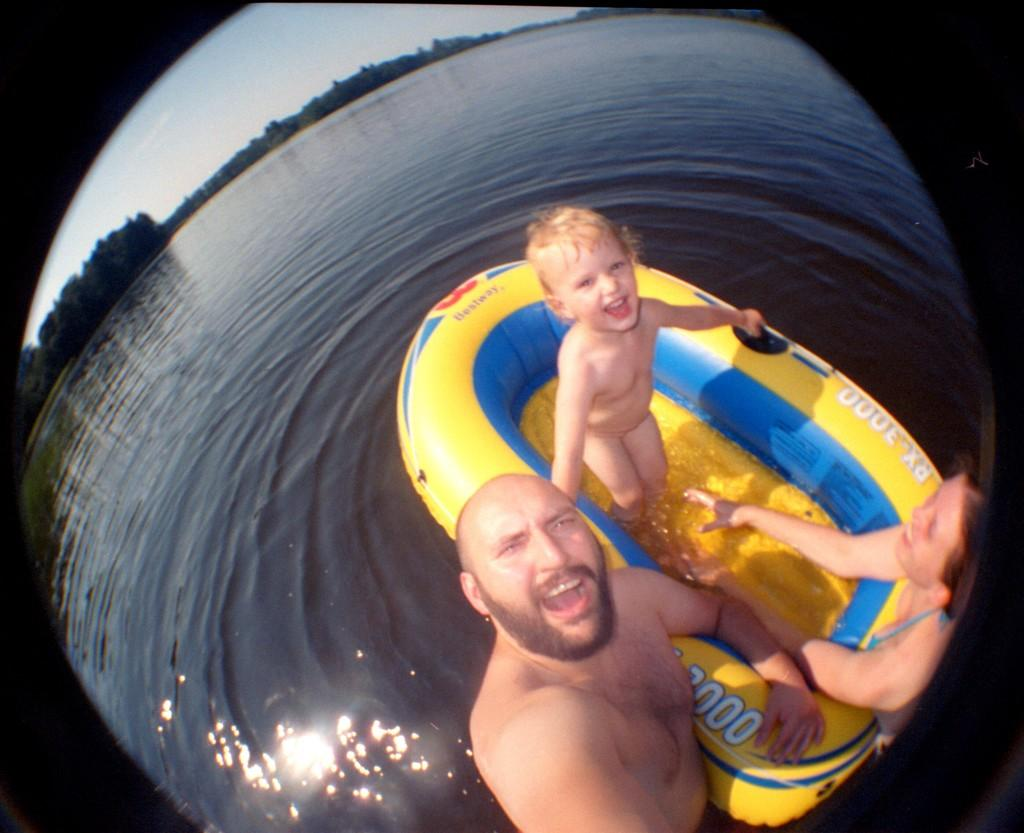How many people are in the image? There are three people in the image: a man, a woman, and a child. What are the man and woman doing in the image? The man and woman are standing in the water. Where is the child located in the image? The child is standing on a rubber boat. What can be seen in the background of the image? There are trees and the sky visible in the background of the image. What type of food is being prepared on the plane in the image? There is no plane present in the image, and therefore no food preparation can be observed. 